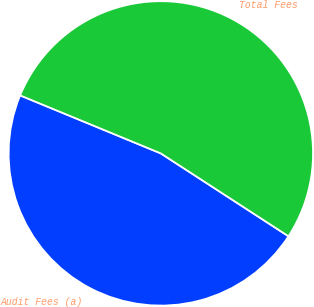Convert chart to OTSL. <chart><loc_0><loc_0><loc_500><loc_500><pie_chart><fcel>Audit Fees (a)<fcel>Total Fees<nl><fcel>47.06%<fcel>52.94%<nl></chart> 